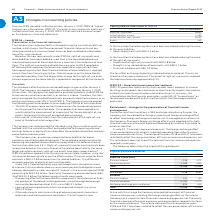According to Lm Ericsson Telephone's financial document, What is the restated financial income in 2018? According to the financial document, 151 (in millions). The relevant text states: "Restated Financial income 151 –50 Financial expenses –2,032 –1,570 Net foreign exchange gains and losses –824 405..." Also, What is the restated total of financial income, expenses and net foreign exchange gains and losses in 2017? According to the financial document, –1,215 (in millions). The relevant text states: "Total –2,705 –1,215..." Also, What is the restated total of financial income, expenses and net foreign exchange gains and losses in 2018? Based on the financial document, the answer is -2,705 (in millions). Also, can you calculate: What is the change between the total of financial income, expenses and net foreign exchange gains and losses in 2018 and 2017? Based on the calculation: -2,705-(-1,215), the result is -1490 (in millions). This is based on the information: "Total –2,705 –1,215 Total –2,705 –1,215..." The key data points involved are: 1,215, 2,705. Also, can you calculate: What is the change in financial income between 2018 and 2017? Based on the calculation: 151-(-50), the result is 201 (in millions). This is based on the information: "Restated Financial income 151 –50 Financial expenses –2,032 –1,570 Net foreign exchange gains and losses –824 405 Restated Financial income 151 –50 Financial expenses –2,032 –1,570 Net foreign exchang..." The key data points involved are: 151, 50. Also, can you calculate: What is the change in the net foreign exchange gains and losses between 2018 and 2017? Based on the calculation: -824-405, the result is -1229 (in millions). This is based on the information: "032 –1,570 Net foreign exchange gains and losses –824 405 –1,570 Net foreign exchange gains and losses –824 405..." The key data points involved are: 405, 824. 